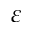<formula> <loc_0><loc_0><loc_500><loc_500>\varepsilon</formula> 